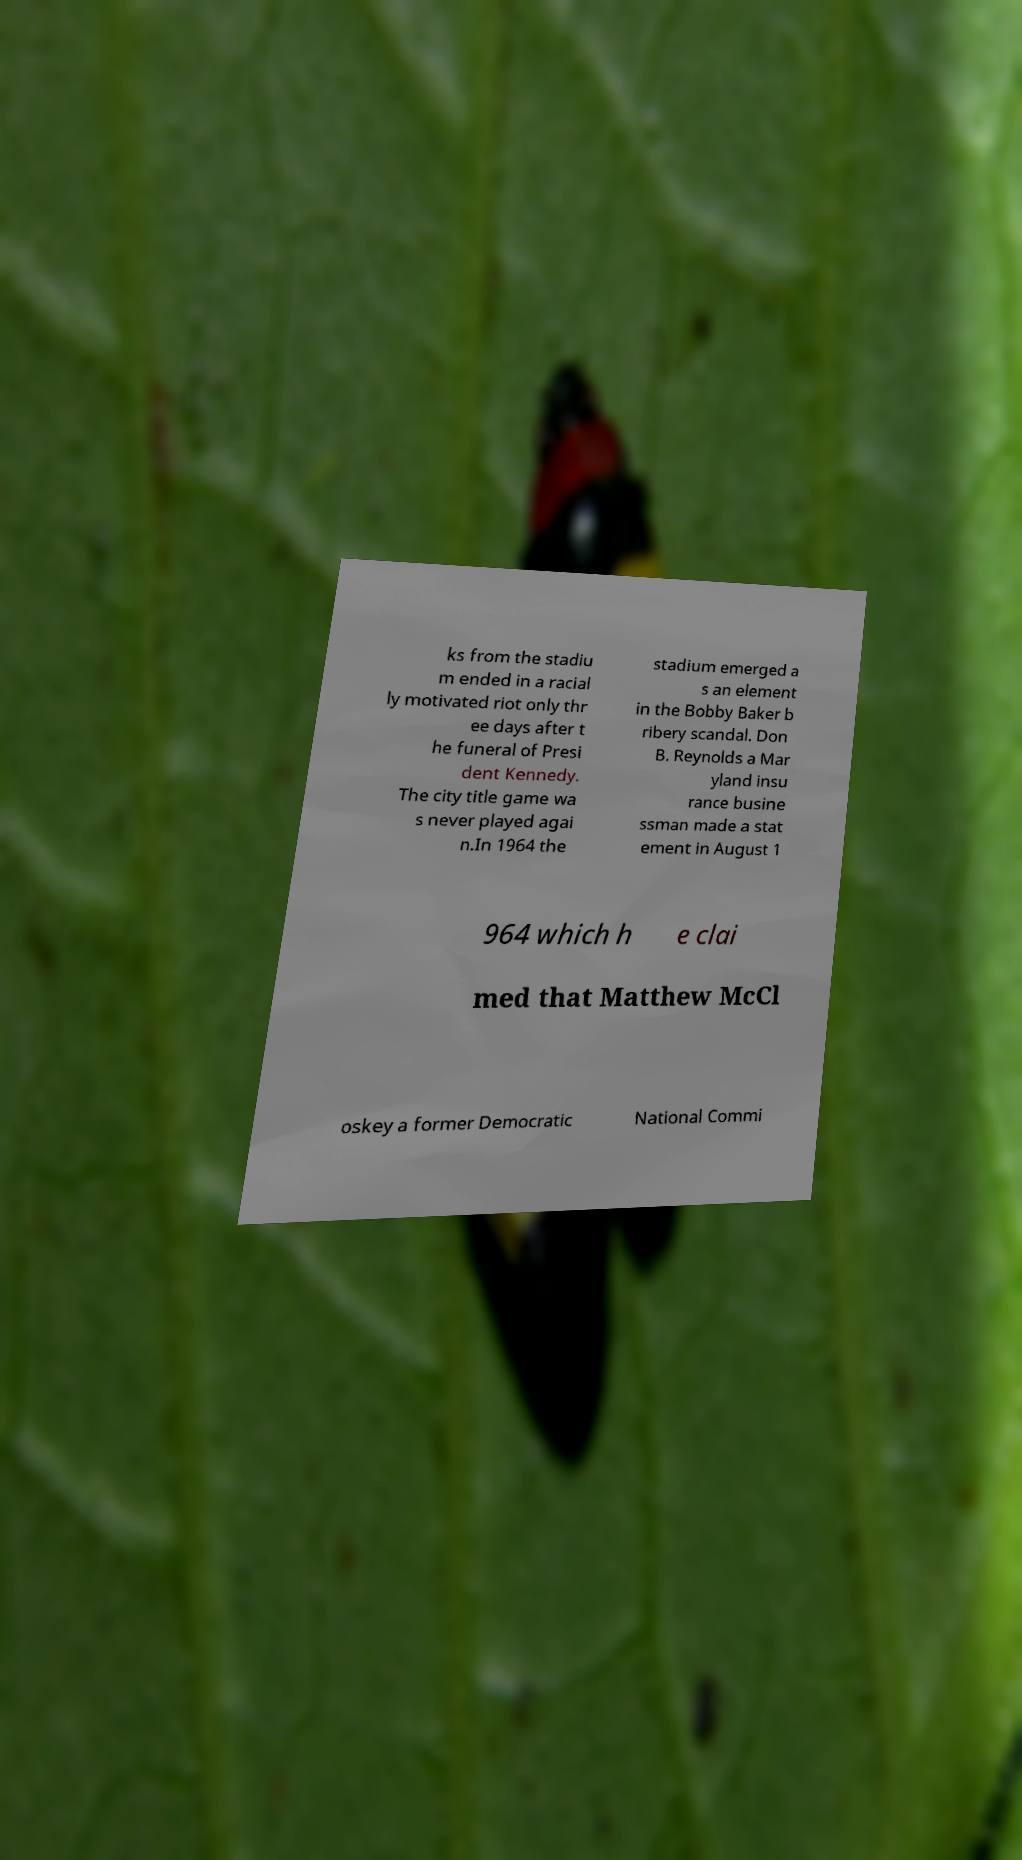Can you read and provide the text displayed in the image?This photo seems to have some interesting text. Can you extract and type it out for me? ks from the stadiu m ended in a racial ly motivated riot only thr ee days after t he funeral of Presi dent Kennedy. The city title game wa s never played agai n.In 1964 the stadium emerged a s an element in the Bobby Baker b ribery scandal. Don B. Reynolds a Mar yland insu rance busine ssman made a stat ement in August 1 964 which h e clai med that Matthew McCl oskey a former Democratic National Commi 